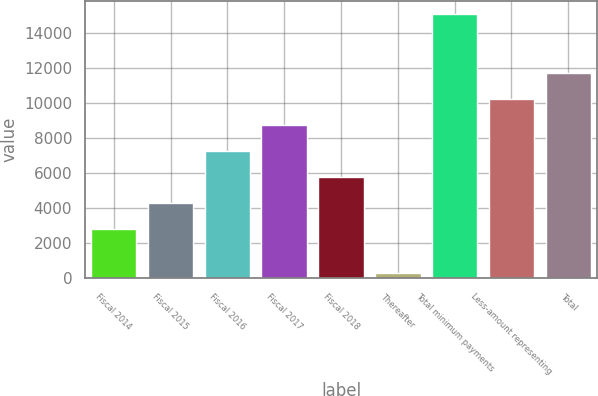Convert chart. <chart><loc_0><loc_0><loc_500><loc_500><bar_chart><fcel>Fiscal 2014<fcel>Fiscal 2015<fcel>Fiscal 2016<fcel>Fiscal 2017<fcel>Fiscal 2018<fcel>Thereafter<fcel>Total minimum payments<fcel>Less-amount representing<fcel>Total<nl><fcel>2822<fcel>4302.3<fcel>7262.9<fcel>8743.2<fcel>5782.6<fcel>300<fcel>15103<fcel>10223.5<fcel>11703.8<nl></chart> 